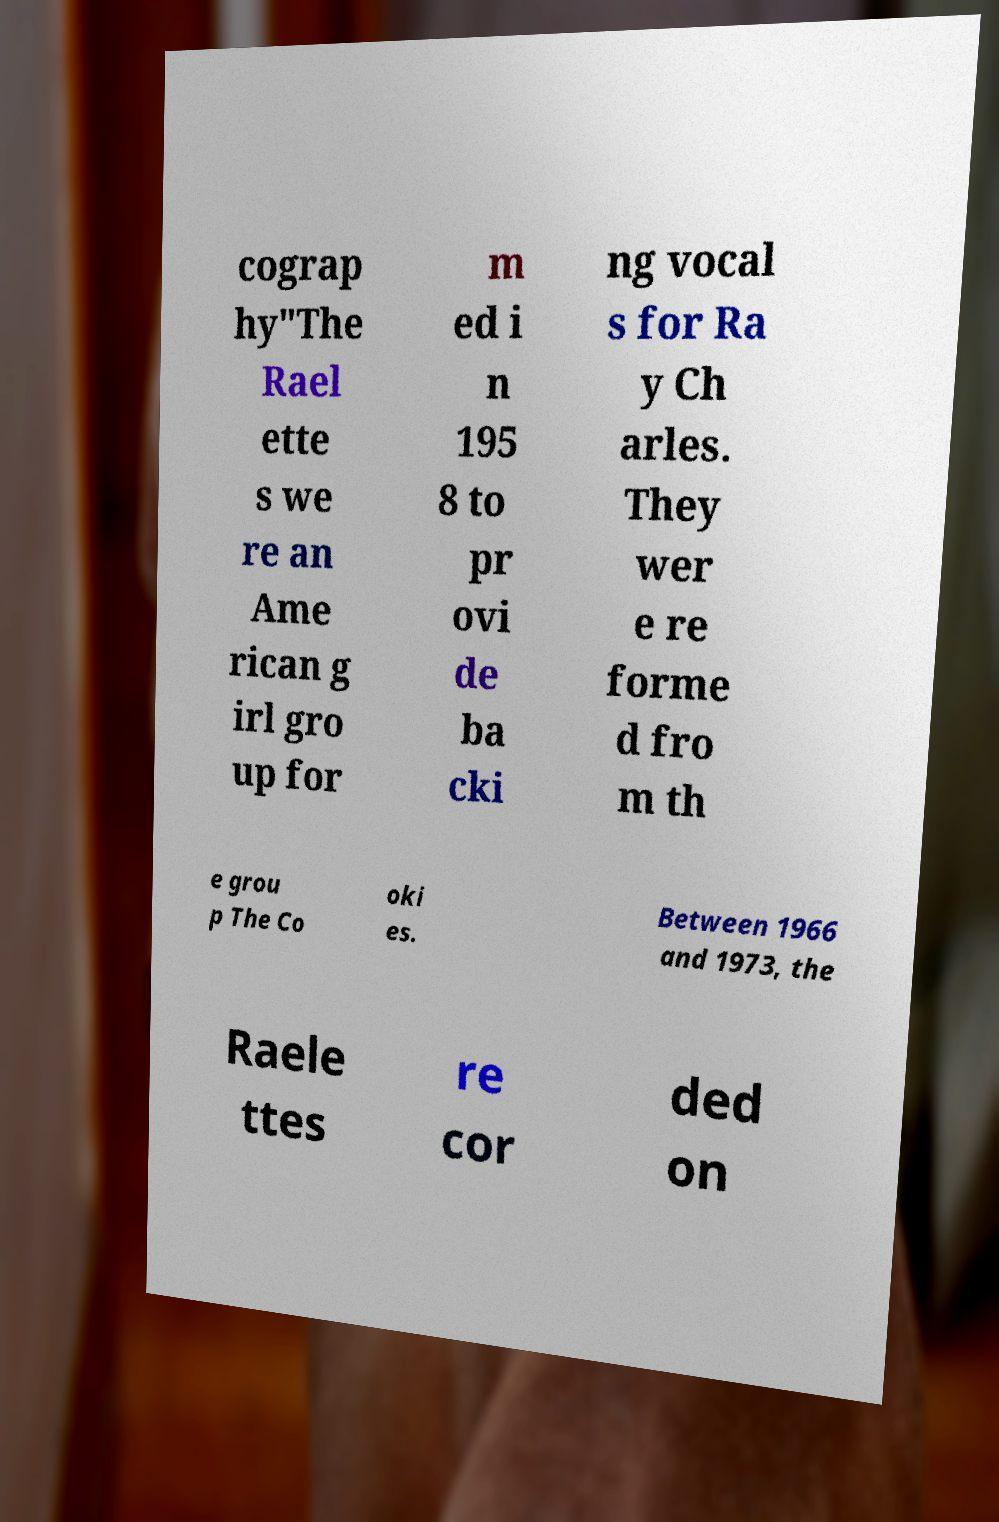What messages or text are displayed in this image? I need them in a readable, typed format. cograp hy"The Rael ette s we re an Ame rican g irl gro up for m ed i n 195 8 to pr ovi de ba cki ng vocal s for Ra y Ch arles. They wer e re forme d fro m th e grou p The Co oki es. Between 1966 and 1973, the Raele ttes re cor ded on 